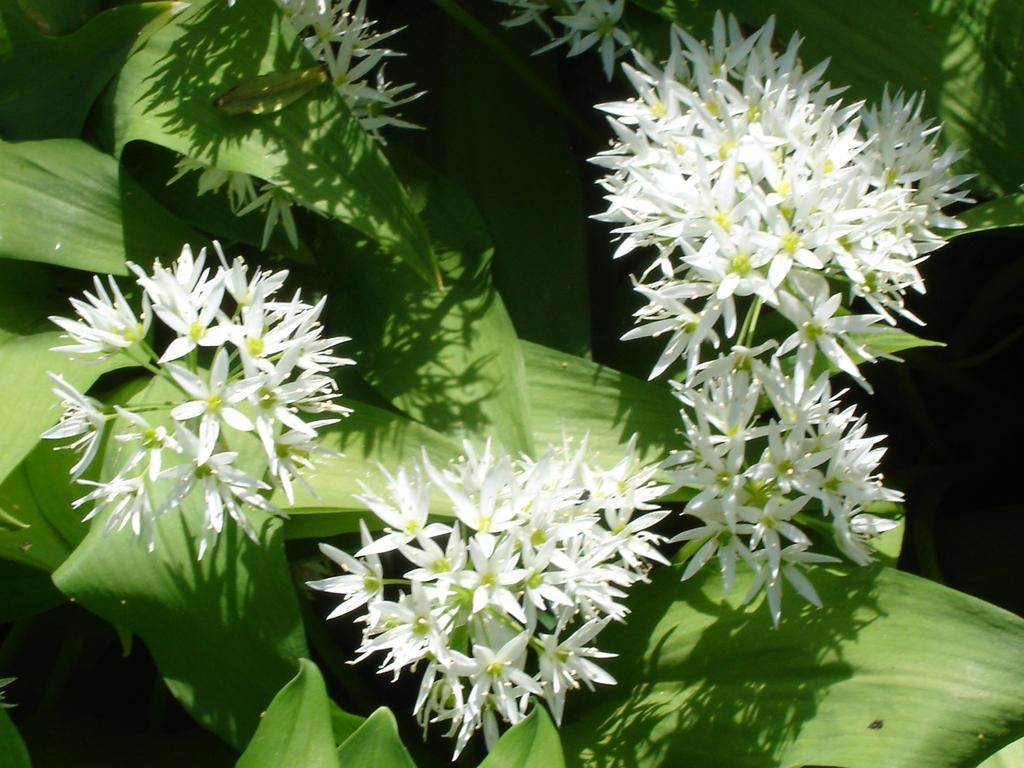What type of plant life is present in the image? There are flowers and leaves in the image. Can you describe the flowers in the image? Unfortunately, the facts provided do not give specific details about the flowers. What is the context or setting of the image? The facts provided do not give information about the context or setting of the image. What type of blood is visible on the desk in the image? There is no mention of a desk or blood in the provided facts, and therefore no such elements can be observed in the image. 